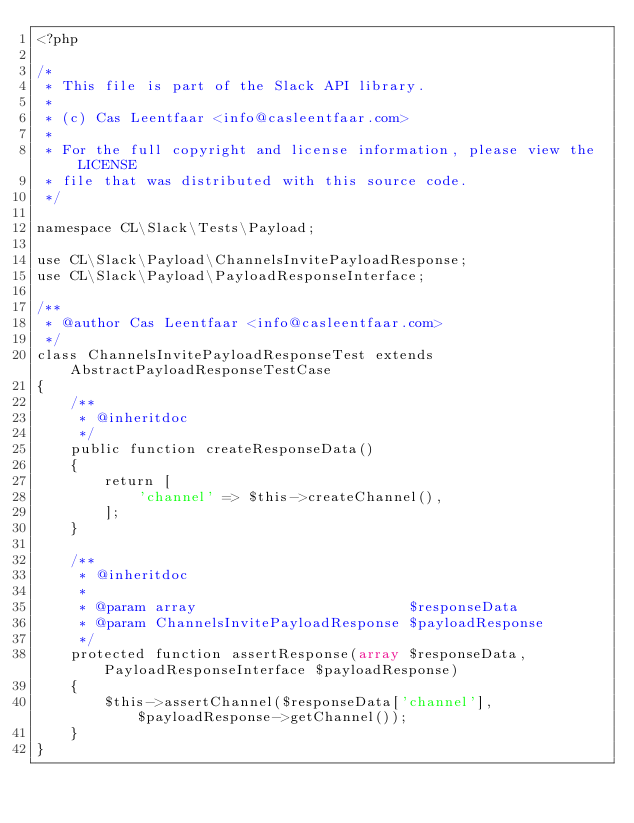Convert code to text. <code><loc_0><loc_0><loc_500><loc_500><_PHP_><?php

/*
 * This file is part of the Slack API library.
 *
 * (c) Cas Leentfaar <info@casleentfaar.com>
 *
 * For the full copyright and license information, please view the LICENSE
 * file that was distributed with this source code.
 */

namespace CL\Slack\Tests\Payload;

use CL\Slack\Payload\ChannelsInvitePayloadResponse;
use CL\Slack\Payload\PayloadResponseInterface;

/**
 * @author Cas Leentfaar <info@casleentfaar.com>
 */
class ChannelsInvitePayloadResponseTest extends AbstractPayloadResponseTestCase
{
    /**
     * @inheritdoc
     */
    public function createResponseData()
    {
        return [
            'channel' => $this->createChannel(),
        ];
    }

    /**
     * @inheritdoc
     *
     * @param array                         $responseData
     * @param ChannelsInvitePayloadResponse $payloadResponse
     */
    protected function assertResponse(array $responseData, PayloadResponseInterface $payloadResponse)
    {
        $this->assertChannel($responseData['channel'], $payloadResponse->getChannel());
    }
}
</code> 